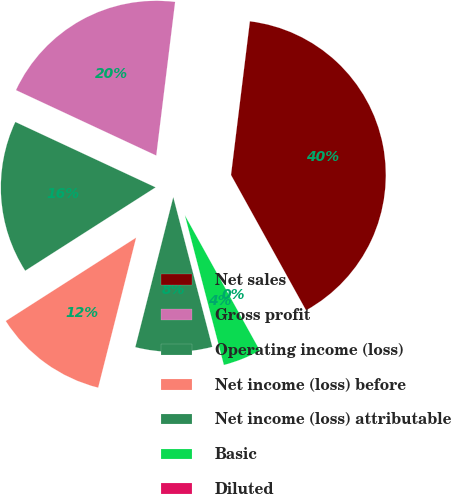<chart> <loc_0><loc_0><loc_500><loc_500><pie_chart><fcel>Net sales<fcel>Gross profit<fcel>Operating income (loss)<fcel>Net income (loss) before<fcel>Net income (loss) attributable<fcel>Basic<fcel>Diluted<nl><fcel>40.0%<fcel>20.0%<fcel>16.0%<fcel>12.0%<fcel>8.0%<fcel>4.0%<fcel>0.0%<nl></chart> 